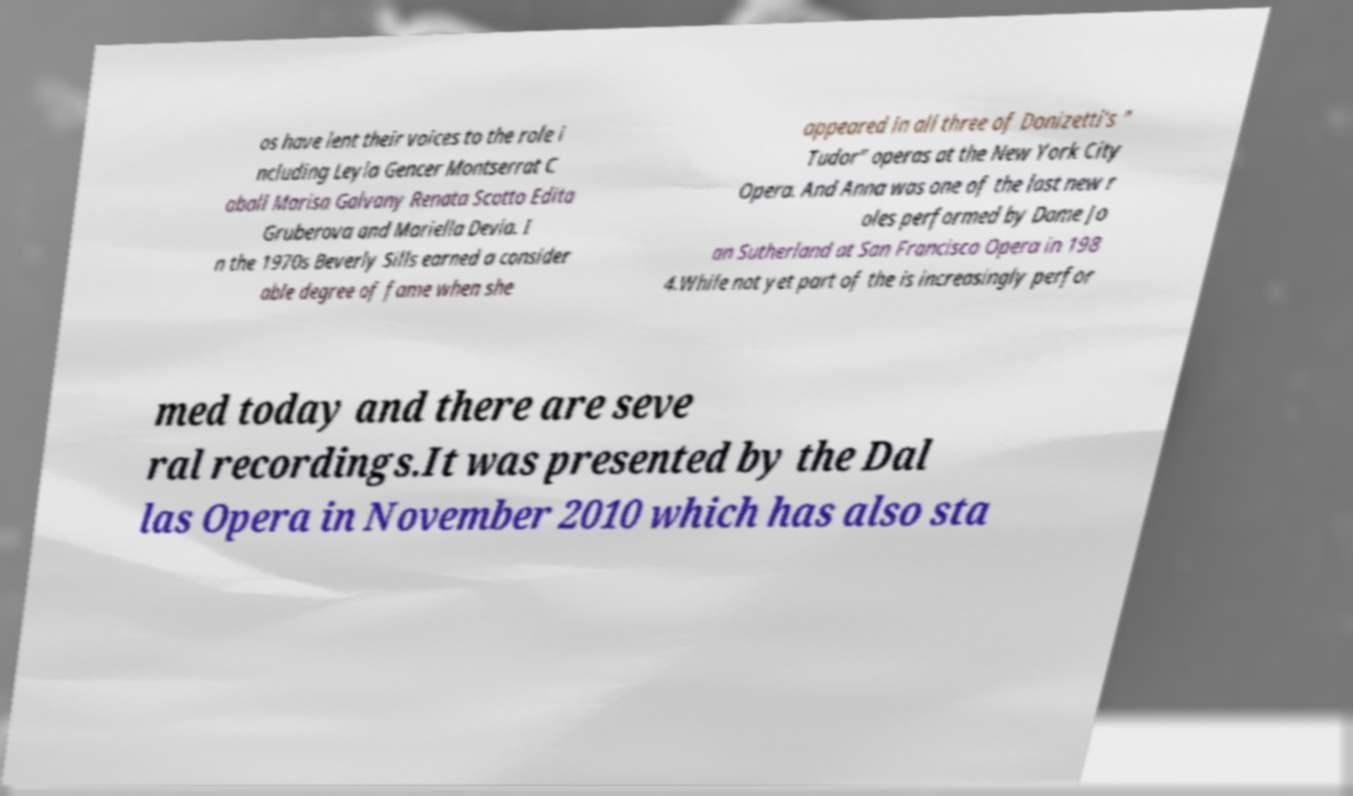What messages or text are displayed in this image? I need them in a readable, typed format. os have lent their voices to the role i ncluding Leyla Gencer Montserrat C aball Marisa Galvany Renata Scotto Edita Gruberova and Mariella Devia. I n the 1970s Beverly Sills earned a consider able degree of fame when she appeared in all three of Donizetti's " Tudor" operas at the New York City Opera. And Anna was one of the last new r oles performed by Dame Jo an Sutherland at San Francisco Opera in 198 4.While not yet part of the is increasingly perfor med today and there are seve ral recordings.It was presented by the Dal las Opera in November 2010 which has also sta 